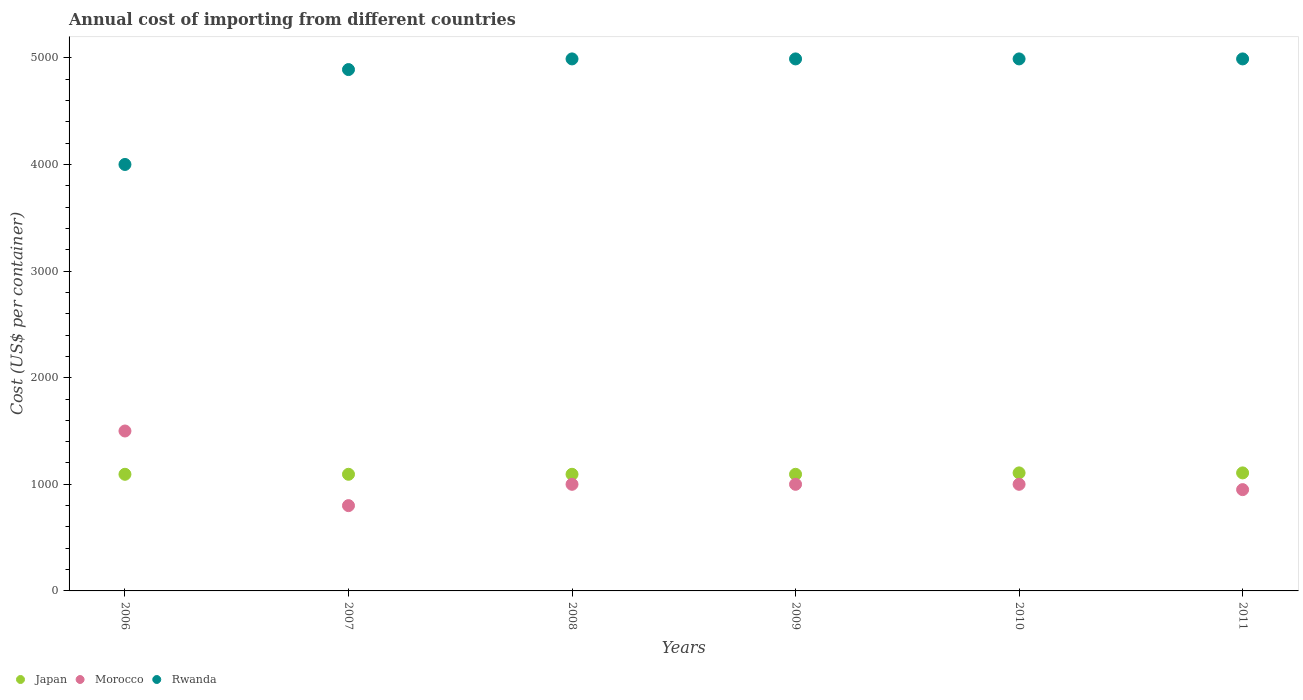How many different coloured dotlines are there?
Your answer should be very brief. 3. What is the total annual cost of importing in Rwanda in 2007?
Ensure brevity in your answer.  4890. Across all years, what is the maximum total annual cost of importing in Morocco?
Ensure brevity in your answer.  1500. Across all years, what is the minimum total annual cost of importing in Morocco?
Your answer should be compact. 800. In which year was the total annual cost of importing in Rwanda maximum?
Provide a short and direct response. 2008. In which year was the total annual cost of importing in Rwanda minimum?
Your answer should be very brief. 2006. What is the total total annual cost of importing in Japan in the graph?
Make the answer very short. 6590. What is the difference between the total annual cost of importing in Japan in 2006 and that in 2007?
Ensure brevity in your answer.  0. What is the difference between the total annual cost of importing in Rwanda in 2006 and the total annual cost of importing in Japan in 2008?
Make the answer very short. 2906. What is the average total annual cost of importing in Morocco per year?
Offer a very short reply. 1041.67. In the year 2011, what is the difference between the total annual cost of importing in Rwanda and total annual cost of importing in Morocco?
Your response must be concise. 4040. What is the ratio of the total annual cost of importing in Japan in 2006 to that in 2008?
Keep it short and to the point. 1. Is the sum of the total annual cost of importing in Rwanda in 2006 and 2007 greater than the maximum total annual cost of importing in Morocco across all years?
Offer a very short reply. Yes. Is it the case that in every year, the sum of the total annual cost of importing in Japan and total annual cost of importing in Morocco  is greater than the total annual cost of importing in Rwanda?
Give a very brief answer. No. Is the total annual cost of importing in Morocco strictly less than the total annual cost of importing in Rwanda over the years?
Your answer should be very brief. Yes. How many dotlines are there?
Your answer should be compact. 3. How many years are there in the graph?
Provide a succinct answer. 6. What is the difference between two consecutive major ticks on the Y-axis?
Keep it short and to the point. 1000. Does the graph contain grids?
Give a very brief answer. No. Where does the legend appear in the graph?
Offer a terse response. Bottom left. How are the legend labels stacked?
Provide a succinct answer. Horizontal. What is the title of the graph?
Your answer should be very brief. Annual cost of importing from different countries. What is the label or title of the X-axis?
Your answer should be very brief. Years. What is the label or title of the Y-axis?
Your answer should be very brief. Cost (US$ per container). What is the Cost (US$ per container) in Japan in 2006?
Your response must be concise. 1094. What is the Cost (US$ per container) in Morocco in 2006?
Your response must be concise. 1500. What is the Cost (US$ per container) of Rwanda in 2006?
Your answer should be compact. 4000. What is the Cost (US$ per container) of Japan in 2007?
Make the answer very short. 1094. What is the Cost (US$ per container) of Morocco in 2007?
Your answer should be compact. 800. What is the Cost (US$ per container) in Rwanda in 2007?
Your answer should be compact. 4890. What is the Cost (US$ per container) of Japan in 2008?
Give a very brief answer. 1094. What is the Cost (US$ per container) in Rwanda in 2008?
Provide a succinct answer. 4990. What is the Cost (US$ per container) of Japan in 2009?
Your answer should be compact. 1094. What is the Cost (US$ per container) in Morocco in 2009?
Give a very brief answer. 1000. What is the Cost (US$ per container) of Rwanda in 2009?
Ensure brevity in your answer.  4990. What is the Cost (US$ per container) in Japan in 2010?
Give a very brief answer. 1107. What is the Cost (US$ per container) in Morocco in 2010?
Provide a short and direct response. 1000. What is the Cost (US$ per container) of Rwanda in 2010?
Keep it short and to the point. 4990. What is the Cost (US$ per container) in Japan in 2011?
Offer a terse response. 1107. What is the Cost (US$ per container) of Morocco in 2011?
Offer a terse response. 950. What is the Cost (US$ per container) of Rwanda in 2011?
Provide a succinct answer. 4990. Across all years, what is the maximum Cost (US$ per container) of Japan?
Offer a terse response. 1107. Across all years, what is the maximum Cost (US$ per container) of Morocco?
Provide a succinct answer. 1500. Across all years, what is the maximum Cost (US$ per container) in Rwanda?
Offer a terse response. 4990. Across all years, what is the minimum Cost (US$ per container) in Japan?
Keep it short and to the point. 1094. Across all years, what is the minimum Cost (US$ per container) in Morocco?
Keep it short and to the point. 800. Across all years, what is the minimum Cost (US$ per container) in Rwanda?
Provide a succinct answer. 4000. What is the total Cost (US$ per container) in Japan in the graph?
Make the answer very short. 6590. What is the total Cost (US$ per container) in Morocco in the graph?
Your answer should be very brief. 6250. What is the total Cost (US$ per container) of Rwanda in the graph?
Offer a very short reply. 2.88e+04. What is the difference between the Cost (US$ per container) of Morocco in 2006 and that in 2007?
Your answer should be compact. 700. What is the difference between the Cost (US$ per container) of Rwanda in 2006 and that in 2007?
Your answer should be very brief. -890. What is the difference between the Cost (US$ per container) of Morocco in 2006 and that in 2008?
Give a very brief answer. 500. What is the difference between the Cost (US$ per container) of Rwanda in 2006 and that in 2008?
Ensure brevity in your answer.  -990. What is the difference between the Cost (US$ per container) of Morocco in 2006 and that in 2009?
Offer a terse response. 500. What is the difference between the Cost (US$ per container) in Rwanda in 2006 and that in 2009?
Your answer should be very brief. -990. What is the difference between the Cost (US$ per container) of Rwanda in 2006 and that in 2010?
Provide a short and direct response. -990. What is the difference between the Cost (US$ per container) in Morocco in 2006 and that in 2011?
Your response must be concise. 550. What is the difference between the Cost (US$ per container) in Rwanda in 2006 and that in 2011?
Offer a terse response. -990. What is the difference between the Cost (US$ per container) of Japan in 2007 and that in 2008?
Offer a terse response. 0. What is the difference between the Cost (US$ per container) in Morocco in 2007 and that in 2008?
Provide a short and direct response. -200. What is the difference between the Cost (US$ per container) of Rwanda in 2007 and that in 2008?
Make the answer very short. -100. What is the difference between the Cost (US$ per container) in Morocco in 2007 and that in 2009?
Give a very brief answer. -200. What is the difference between the Cost (US$ per container) of Rwanda in 2007 and that in 2009?
Provide a short and direct response. -100. What is the difference between the Cost (US$ per container) of Morocco in 2007 and that in 2010?
Your answer should be very brief. -200. What is the difference between the Cost (US$ per container) of Rwanda in 2007 and that in 2010?
Provide a succinct answer. -100. What is the difference between the Cost (US$ per container) of Japan in 2007 and that in 2011?
Offer a terse response. -13. What is the difference between the Cost (US$ per container) in Morocco in 2007 and that in 2011?
Your answer should be compact. -150. What is the difference between the Cost (US$ per container) of Rwanda in 2007 and that in 2011?
Your response must be concise. -100. What is the difference between the Cost (US$ per container) of Morocco in 2008 and that in 2009?
Give a very brief answer. 0. What is the difference between the Cost (US$ per container) in Rwanda in 2008 and that in 2009?
Your answer should be compact. 0. What is the difference between the Cost (US$ per container) of Morocco in 2008 and that in 2010?
Provide a succinct answer. 0. What is the difference between the Cost (US$ per container) in Rwanda in 2008 and that in 2010?
Ensure brevity in your answer.  0. What is the difference between the Cost (US$ per container) in Japan in 2008 and that in 2011?
Your answer should be very brief. -13. What is the difference between the Cost (US$ per container) of Rwanda in 2008 and that in 2011?
Give a very brief answer. 0. What is the difference between the Cost (US$ per container) in Morocco in 2009 and that in 2010?
Your answer should be compact. 0. What is the difference between the Cost (US$ per container) of Rwanda in 2009 and that in 2011?
Give a very brief answer. 0. What is the difference between the Cost (US$ per container) of Japan in 2010 and that in 2011?
Your answer should be very brief. 0. What is the difference between the Cost (US$ per container) of Rwanda in 2010 and that in 2011?
Offer a terse response. 0. What is the difference between the Cost (US$ per container) of Japan in 2006 and the Cost (US$ per container) of Morocco in 2007?
Keep it short and to the point. 294. What is the difference between the Cost (US$ per container) in Japan in 2006 and the Cost (US$ per container) in Rwanda in 2007?
Offer a terse response. -3796. What is the difference between the Cost (US$ per container) in Morocco in 2006 and the Cost (US$ per container) in Rwanda in 2007?
Ensure brevity in your answer.  -3390. What is the difference between the Cost (US$ per container) in Japan in 2006 and the Cost (US$ per container) in Morocco in 2008?
Provide a short and direct response. 94. What is the difference between the Cost (US$ per container) of Japan in 2006 and the Cost (US$ per container) of Rwanda in 2008?
Your answer should be very brief. -3896. What is the difference between the Cost (US$ per container) of Morocco in 2006 and the Cost (US$ per container) of Rwanda in 2008?
Your response must be concise. -3490. What is the difference between the Cost (US$ per container) in Japan in 2006 and the Cost (US$ per container) in Morocco in 2009?
Offer a very short reply. 94. What is the difference between the Cost (US$ per container) of Japan in 2006 and the Cost (US$ per container) of Rwanda in 2009?
Give a very brief answer. -3896. What is the difference between the Cost (US$ per container) of Morocco in 2006 and the Cost (US$ per container) of Rwanda in 2009?
Your response must be concise. -3490. What is the difference between the Cost (US$ per container) in Japan in 2006 and the Cost (US$ per container) in Morocco in 2010?
Keep it short and to the point. 94. What is the difference between the Cost (US$ per container) in Japan in 2006 and the Cost (US$ per container) in Rwanda in 2010?
Offer a terse response. -3896. What is the difference between the Cost (US$ per container) in Morocco in 2006 and the Cost (US$ per container) in Rwanda in 2010?
Your response must be concise. -3490. What is the difference between the Cost (US$ per container) in Japan in 2006 and the Cost (US$ per container) in Morocco in 2011?
Keep it short and to the point. 144. What is the difference between the Cost (US$ per container) of Japan in 2006 and the Cost (US$ per container) of Rwanda in 2011?
Offer a very short reply. -3896. What is the difference between the Cost (US$ per container) of Morocco in 2006 and the Cost (US$ per container) of Rwanda in 2011?
Provide a short and direct response. -3490. What is the difference between the Cost (US$ per container) in Japan in 2007 and the Cost (US$ per container) in Morocco in 2008?
Your answer should be compact. 94. What is the difference between the Cost (US$ per container) in Japan in 2007 and the Cost (US$ per container) in Rwanda in 2008?
Offer a very short reply. -3896. What is the difference between the Cost (US$ per container) in Morocco in 2007 and the Cost (US$ per container) in Rwanda in 2008?
Make the answer very short. -4190. What is the difference between the Cost (US$ per container) of Japan in 2007 and the Cost (US$ per container) of Morocco in 2009?
Give a very brief answer. 94. What is the difference between the Cost (US$ per container) of Japan in 2007 and the Cost (US$ per container) of Rwanda in 2009?
Your answer should be very brief. -3896. What is the difference between the Cost (US$ per container) of Morocco in 2007 and the Cost (US$ per container) of Rwanda in 2009?
Your answer should be very brief. -4190. What is the difference between the Cost (US$ per container) in Japan in 2007 and the Cost (US$ per container) in Morocco in 2010?
Your response must be concise. 94. What is the difference between the Cost (US$ per container) of Japan in 2007 and the Cost (US$ per container) of Rwanda in 2010?
Your answer should be compact. -3896. What is the difference between the Cost (US$ per container) in Morocco in 2007 and the Cost (US$ per container) in Rwanda in 2010?
Give a very brief answer. -4190. What is the difference between the Cost (US$ per container) in Japan in 2007 and the Cost (US$ per container) in Morocco in 2011?
Your response must be concise. 144. What is the difference between the Cost (US$ per container) of Japan in 2007 and the Cost (US$ per container) of Rwanda in 2011?
Ensure brevity in your answer.  -3896. What is the difference between the Cost (US$ per container) in Morocco in 2007 and the Cost (US$ per container) in Rwanda in 2011?
Provide a short and direct response. -4190. What is the difference between the Cost (US$ per container) in Japan in 2008 and the Cost (US$ per container) in Morocco in 2009?
Your response must be concise. 94. What is the difference between the Cost (US$ per container) in Japan in 2008 and the Cost (US$ per container) in Rwanda in 2009?
Give a very brief answer. -3896. What is the difference between the Cost (US$ per container) of Morocco in 2008 and the Cost (US$ per container) of Rwanda in 2009?
Your answer should be compact. -3990. What is the difference between the Cost (US$ per container) in Japan in 2008 and the Cost (US$ per container) in Morocco in 2010?
Offer a terse response. 94. What is the difference between the Cost (US$ per container) of Japan in 2008 and the Cost (US$ per container) of Rwanda in 2010?
Ensure brevity in your answer.  -3896. What is the difference between the Cost (US$ per container) of Morocco in 2008 and the Cost (US$ per container) of Rwanda in 2010?
Offer a terse response. -3990. What is the difference between the Cost (US$ per container) in Japan in 2008 and the Cost (US$ per container) in Morocco in 2011?
Offer a very short reply. 144. What is the difference between the Cost (US$ per container) in Japan in 2008 and the Cost (US$ per container) in Rwanda in 2011?
Your answer should be very brief. -3896. What is the difference between the Cost (US$ per container) in Morocco in 2008 and the Cost (US$ per container) in Rwanda in 2011?
Offer a very short reply. -3990. What is the difference between the Cost (US$ per container) of Japan in 2009 and the Cost (US$ per container) of Morocco in 2010?
Keep it short and to the point. 94. What is the difference between the Cost (US$ per container) in Japan in 2009 and the Cost (US$ per container) in Rwanda in 2010?
Give a very brief answer. -3896. What is the difference between the Cost (US$ per container) in Morocco in 2009 and the Cost (US$ per container) in Rwanda in 2010?
Offer a terse response. -3990. What is the difference between the Cost (US$ per container) in Japan in 2009 and the Cost (US$ per container) in Morocco in 2011?
Your response must be concise. 144. What is the difference between the Cost (US$ per container) of Japan in 2009 and the Cost (US$ per container) of Rwanda in 2011?
Offer a terse response. -3896. What is the difference between the Cost (US$ per container) in Morocco in 2009 and the Cost (US$ per container) in Rwanda in 2011?
Your answer should be compact. -3990. What is the difference between the Cost (US$ per container) in Japan in 2010 and the Cost (US$ per container) in Morocco in 2011?
Ensure brevity in your answer.  157. What is the difference between the Cost (US$ per container) of Japan in 2010 and the Cost (US$ per container) of Rwanda in 2011?
Offer a very short reply. -3883. What is the difference between the Cost (US$ per container) in Morocco in 2010 and the Cost (US$ per container) in Rwanda in 2011?
Keep it short and to the point. -3990. What is the average Cost (US$ per container) of Japan per year?
Provide a succinct answer. 1098.33. What is the average Cost (US$ per container) of Morocco per year?
Offer a very short reply. 1041.67. What is the average Cost (US$ per container) of Rwanda per year?
Provide a succinct answer. 4808.33. In the year 2006, what is the difference between the Cost (US$ per container) in Japan and Cost (US$ per container) in Morocco?
Your response must be concise. -406. In the year 2006, what is the difference between the Cost (US$ per container) of Japan and Cost (US$ per container) of Rwanda?
Provide a succinct answer. -2906. In the year 2006, what is the difference between the Cost (US$ per container) in Morocco and Cost (US$ per container) in Rwanda?
Provide a succinct answer. -2500. In the year 2007, what is the difference between the Cost (US$ per container) of Japan and Cost (US$ per container) of Morocco?
Make the answer very short. 294. In the year 2007, what is the difference between the Cost (US$ per container) in Japan and Cost (US$ per container) in Rwanda?
Keep it short and to the point. -3796. In the year 2007, what is the difference between the Cost (US$ per container) of Morocco and Cost (US$ per container) of Rwanda?
Give a very brief answer. -4090. In the year 2008, what is the difference between the Cost (US$ per container) of Japan and Cost (US$ per container) of Morocco?
Provide a succinct answer. 94. In the year 2008, what is the difference between the Cost (US$ per container) of Japan and Cost (US$ per container) of Rwanda?
Offer a terse response. -3896. In the year 2008, what is the difference between the Cost (US$ per container) of Morocco and Cost (US$ per container) of Rwanda?
Ensure brevity in your answer.  -3990. In the year 2009, what is the difference between the Cost (US$ per container) in Japan and Cost (US$ per container) in Morocco?
Make the answer very short. 94. In the year 2009, what is the difference between the Cost (US$ per container) in Japan and Cost (US$ per container) in Rwanda?
Offer a very short reply. -3896. In the year 2009, what is the difference between the Cost (US$ per container) of Morocco and Cost (US$ per container) of Rwanda?
Your answer should be very brief. -3990. In the year 2010, what is the difference between the Cost (US$ per container) of Japan and Cost (US$ per container) of Morocco?
Provide a succinct answer. 107. In the year 2010, what is the difference between the Cost (US$ per container) of Japan and Cost (US$ per container) of Rwanda?
Keep it short and to the point. -3883. In the year 2010, what is the difference between the Cost (US$ per container) in Morocco and Cost (US$ per container) in Rwanda?
Your response must be concise. -3990. In the year 2011, what is the difference between the Cost (US$ per container) of Japan and Cost (US$ per container) of Morocco?
Your answer should be very brief. 157. In the year 2011, what is the difference between the Cost (US$ per container) in Japan and Cost (US$ per container) in Rwanda?
Your response must be concise. -3883. In the year 2011, what is the difference between the Cost (US$ per container) in Morocco and Cost (US$ per container) in Rwanda?
Your answer should be very brief. -4040. What is the ratio of the Cost (US$ per container) of Japan in 2006 to that in 2007?
Your response must be concise. 1. What is the ratio of the Cost (US$ per container) of Morocco in 2006 to that in 2007?
Your response must be concise. 1.88. What is the ratio of the Cost (US$ per container) in Rwanda in 2006 to that in 2007?
Keep it short and to the point. 0.82. What is the ratio of the Cost (US$ per container) in Japan in 2006 to that in 2008?
Offer a very short reply. 1. What is the ratio of the Cost (US$ per container) of Rwanda in 2006 to that in 2008?
Your answer should be compact. 0.8. What is the ratio of the Cost (US$ per container) of Japan in 2006 to that in 2009?
Your answer should be compact. 1. What is the ratio of the Cost (US$ per container) in Morocco in 2006 to that in 2009?
Offer a terse response. 1.5. What is the ratio of the Cost (US$ per container) in Rwanda in 2006 to that in 2009?
Provide a short and direct response. 0.8. What is the ratio of the Cost (US$ per container) of Japan in 2006 to that in 2010?
Your response must be concise. 0.99. What is the ratio of the Cost (US$ per container) of Morocco in 2006 to that in 2010?
Make the answer very short. 1.5. What is the ratio of the Cost (US$ per container) of Rwanda in 2006 to that in 2010?
Make the answer very short. 0.8. What is the ratio of the Cost (US$ per container) in Japan in 2006 to that in 2011?
Your answer should be compact. 0.99. What is the ratio of the Cost (US$ per container) in Morocco in 2006 to that in 2011?
Offer a very short reply. 1.58. What is the ratio of the Cost (US$ per container) of Rwanda in 2006 to that in 2011?
Provide a short and direct response. 0.8. What is the ratio of the Cost (US$ per container) of Morocco in 2007 to that in 2008?
Ensure brevity in your answer.  0.8. What is the ratio of the Cost (US$ per container) of Japan in 2007 to that in 2010?
Make the answer very short. 0.99. What is the ratio of the Cost (US$ per container) in Morocco in 2007 to that in 2010?
Offer a very short reply. 0.8. What is the ratio of the Cost (US$ per container) in Rwanda in 2007 to that in 2010?
Offer a very short reply. 0.98. What is the ratio of the Cost (US$ per container) in Japan in 2007 to that in 2011?
Ensure brevity in your answer.  0.99. What is the ratio of the Cost (US$ per container) of Morocco in 2007 to that in 2011?
Your response must be concise. 0.84. What is the ratio of the Cost (US$ per container) in Rwanda in 2007 to that in 2011?
Give a very brief answer. 0.98. What is the ratio of the Cost (US$ per container) of Japan in 2008 to that in 2010?
Give a very brief answer. 0.99. What is the ratio of the Cost (US$ per container) of Rwanda in 2008 to that in 2010?
Offer a terse response. 1. What is the ratio of the Cost (US$ per container) of Japan in 2008 to that in 2011?
Give a very brief answer. 0.99. What is the ratio of the Cost (US$ per container) of Morocco in 2008 to that in 2011?
Offer a terse response. 1.05. What is the ratio of the Cost (US$ per container) in Japan in 2009 to that in 2010?
Keep it short and to the point. 0.99. What is the ratio of the Cost (US$ per container) in Morocco in 2009 to that in 2010?
Give a very brief answer. 1. What is the ratio of the Cost (US$ per container) in Japan in 2009 to that in 2011?
Your response must be concise. 0.99. What is the ratio of the Cost (US$ per container) in Morocco in 2009 to that in 2011?
Your answer should be very brief. 1.05. What is the ratio of the Cost (US$ per container) of Rwanda in 2009 to that in 2011?
Your answer should be compact. 1. What is the ratio of the Cost (US$ per container) of Japan in 2010 to that in 2011?
Keep it short and to the point. 1. What is the ratio of the Cost (US$ per container) in Morocco in 2010 to that in 2011?
Keep it short and to the point. 1.05. What is the ratio of the Cost (US$ per container) of Rwanda in 2010 to that in 2011?
Offer a terse response. 1. What is the difference between the highest and the second highest Cost (US$ per container) in Morocco?
Keep it short and to the point. 500. What is the difference between the highest and the lowest Cost (US$ per container) in Japan?
Make the answer very short. 13. What is the difference between the highest and the lowest Cost (US$ per container) of Morocco?
Your answer should be very brief. 700. What is the difference between the highest and the lowest Cost (US$ per container) in Rwanda?
Make the answer very short. 990. 